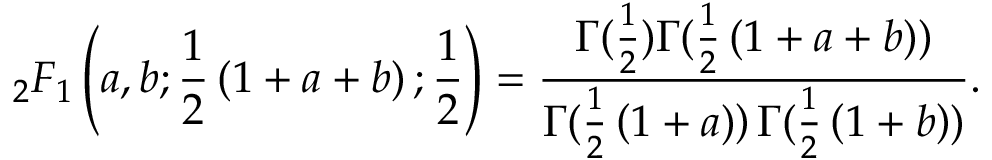<formula> <loc_0><loc_0><loc_500><loc_500>_ { 2 } F _ { 1 } \left ( a , b ; { \frac { 1 } { 2 } } \left ( 1 + a + b \right ) ; { \frac { 1 } { 2 } } \right ) = { \frac { \Gamma ( { \frac { 1 } { 2 } } ) \Gamma ( { \frac { 1 } { 2 } } \left ( 1 + a + b \right ) ) } { \Gamma ( { \frac { 1 } { 2 } } \left ( 1 + a ) \right ) \Gamma ( { \frac { 1 } { 2 } } \left ( 1 + b \right ) ) } } .</formula> 